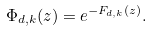<formula> <loc_0><loc_0><loc_500><loc_500>\Phi _ { d , k } ( { z } ) = e ^ { - F _ { d , k } ( { z } ) } .</formula> 